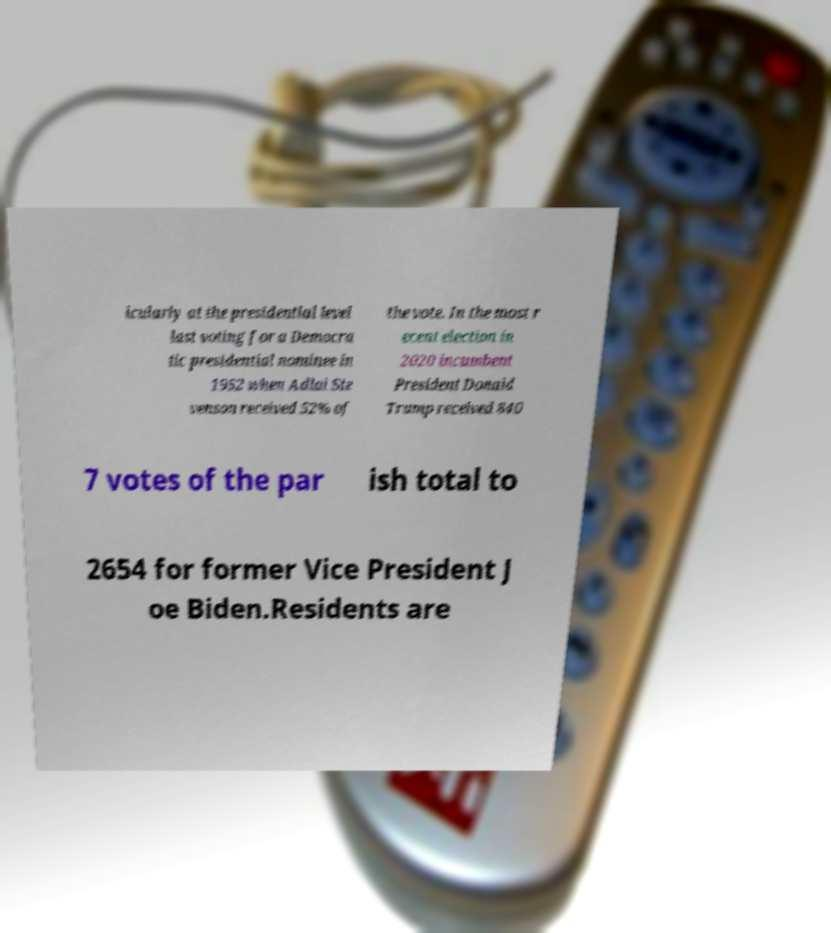Could you extract and type out the text from this image? icularly at the presidential level last voting for a Democra tic presidential nominee in 1952 when Adlai Ste venson received 52% of the vote. In the most r ecent election in 2020 incumbent President Donald Trump received 840 7 votes of the par ish total to 2654 for former Vice President J oe Biden.Residents are 